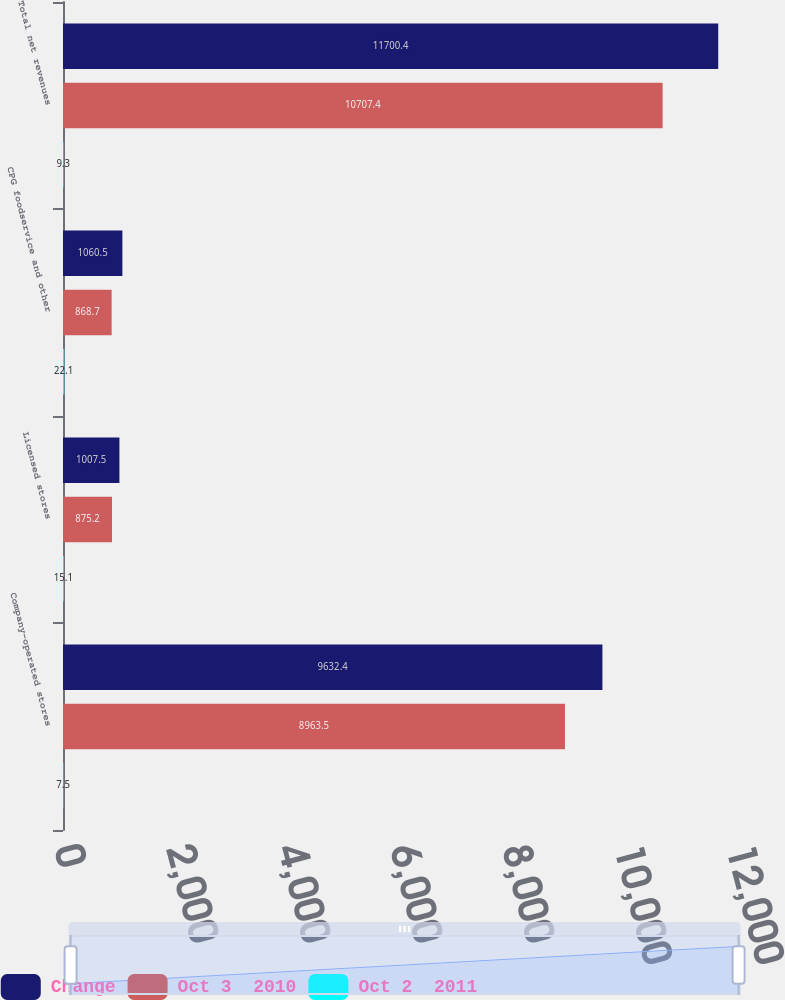Convert chart to OTSL. <chart><loc_0><loc_0><loc_500><loc_500><stacked_bar_chart><ecel><fcel>Company-operated stores<fcel>Licensed stores<fcel>CPG foodservice and other<fcel>Total net revenues<nl><fcel>Change<fcel>9632.4<fcel>1007.5<fcel>1060.5<fcel>11700.4<nl><fcel>Oct 3  2010<fcel>8963.5<fcel>875.2<fcel>868.7<fcel>10707.4<nl><fcel>Oct 2  2011<fcel>7.5<fcel>15.1<fcel>22.1<fcel>9.3<nl></chart> 